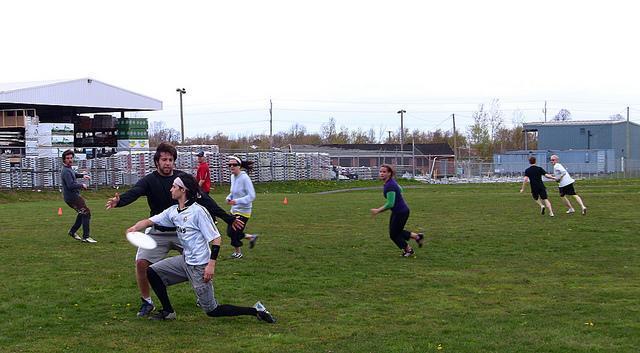How many people are in the photo?
Give a very brief answer. 3. How many horses are to the left of the light pole?
Give a very brief answer. 0. 